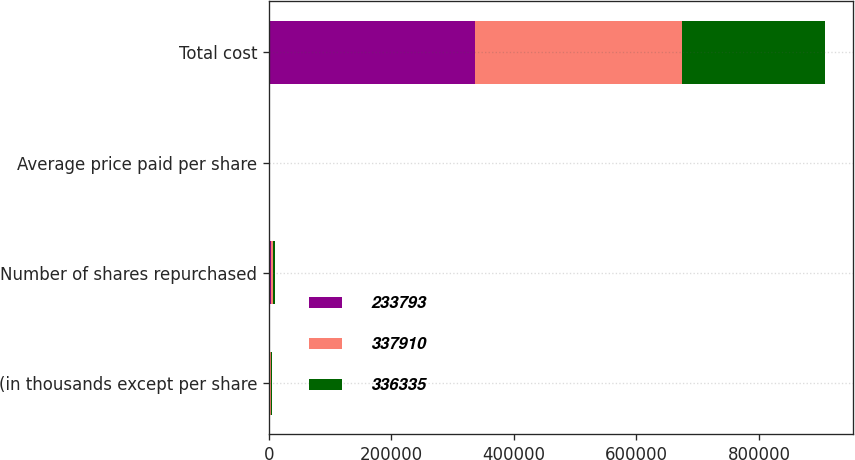Convert chart to OTSL. <chart><loc_0><loc_0><loc_500><loc_500><stacked_bar_chart><ecel><fcel>(in thousands except per share<fcel>Number of shares repurchased<fcel>Average price paid per share<fcel>Total cost<nl><fcel>233793<fcel>2016<fcel>3700<fcel>90.9<fcel>336335<nl><fcel>337910<fcel>2015<fcel>3833<fcel>88.16<fcel>337910<nl><fcel>336335<fcel>2014<fcel>2977<fcel>78.54<fcel>233793<nl></chart> 